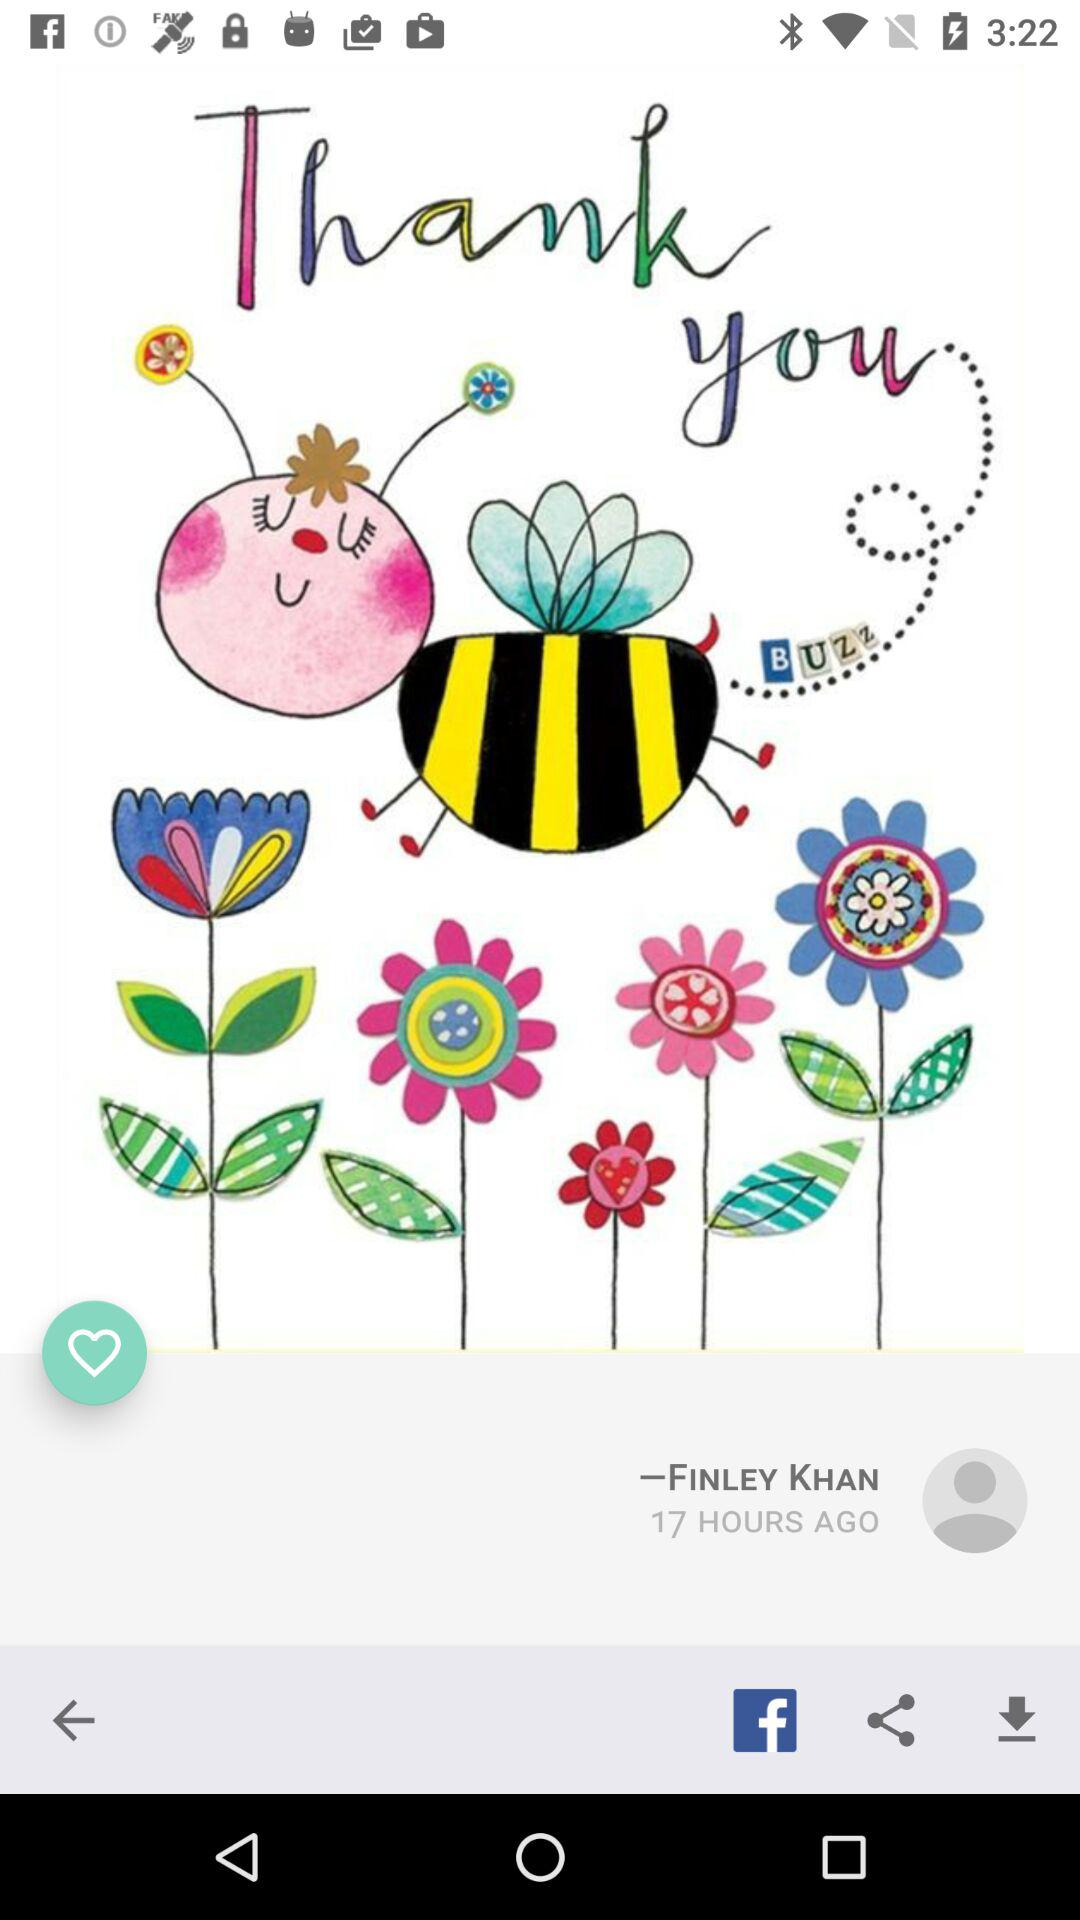How many hours ago was this post made?
Answer the question using a single word or phrase. 17 